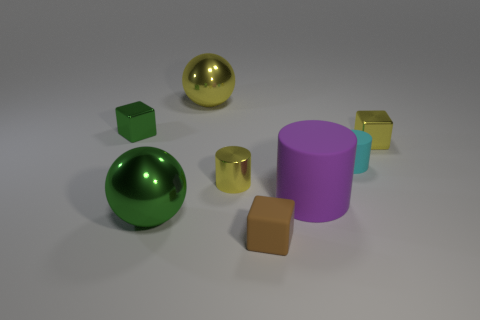Add 2 large cyan matte cubes. How many objects exist? 10 Subtract all blocks. How many objects are left? 5 Subtract all big metallic things. Subtract all yellow things. How many objects are left? 3 Add 3 large green balls. How many large green balls are left? 4 Add 3 large metallic objects. How many large metallic objects exist? 5 Subtract 1 brown blocks. How many objects are left? 7 